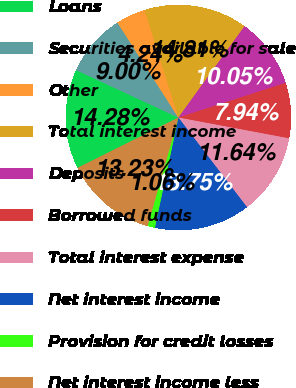<chart> <loc_0><loc_0><loc_500><loc_500><pie_chart><fcel>Loans<fcel>Securities available for sale<fcel>Other<fcel>Total interest income<fcel>Deposits<fcel>Borrowed funds<fcel>Total interest expense<fcel>Net interest income<fcel>Provision for credit losses<fcel>Net interest income less<nl><fcel>14.28%<fcel>9.0%<fcel>4.24%<fcel>14.81%<fcel>10.05%<fcel>7.94%<fcel>11.64%<fcel>13.75%<fcel>1.06%<fcel>13.23%<nl></chart> 